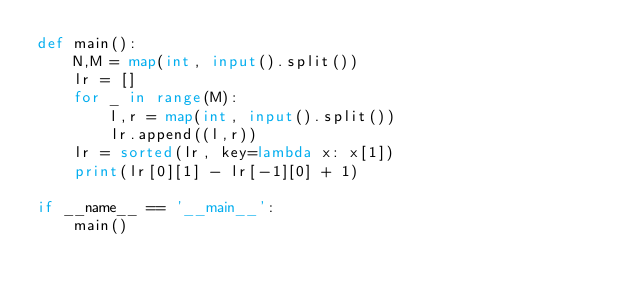Convert code to text. <code><loc_0><loc_0><loc_500><loc_500><_Python_>def main():
    N,M = map(int, input().split())
    lr = []
    for _ in range(M):
        l,r = map(int, input().split())
        lr.append((l,r))
    lr = sorted(lr, key=lambda x: x[1])
    print(lr[0][1] - lr[-1][0] + 1)

if __name__ == '__main__':
    main()</code> 